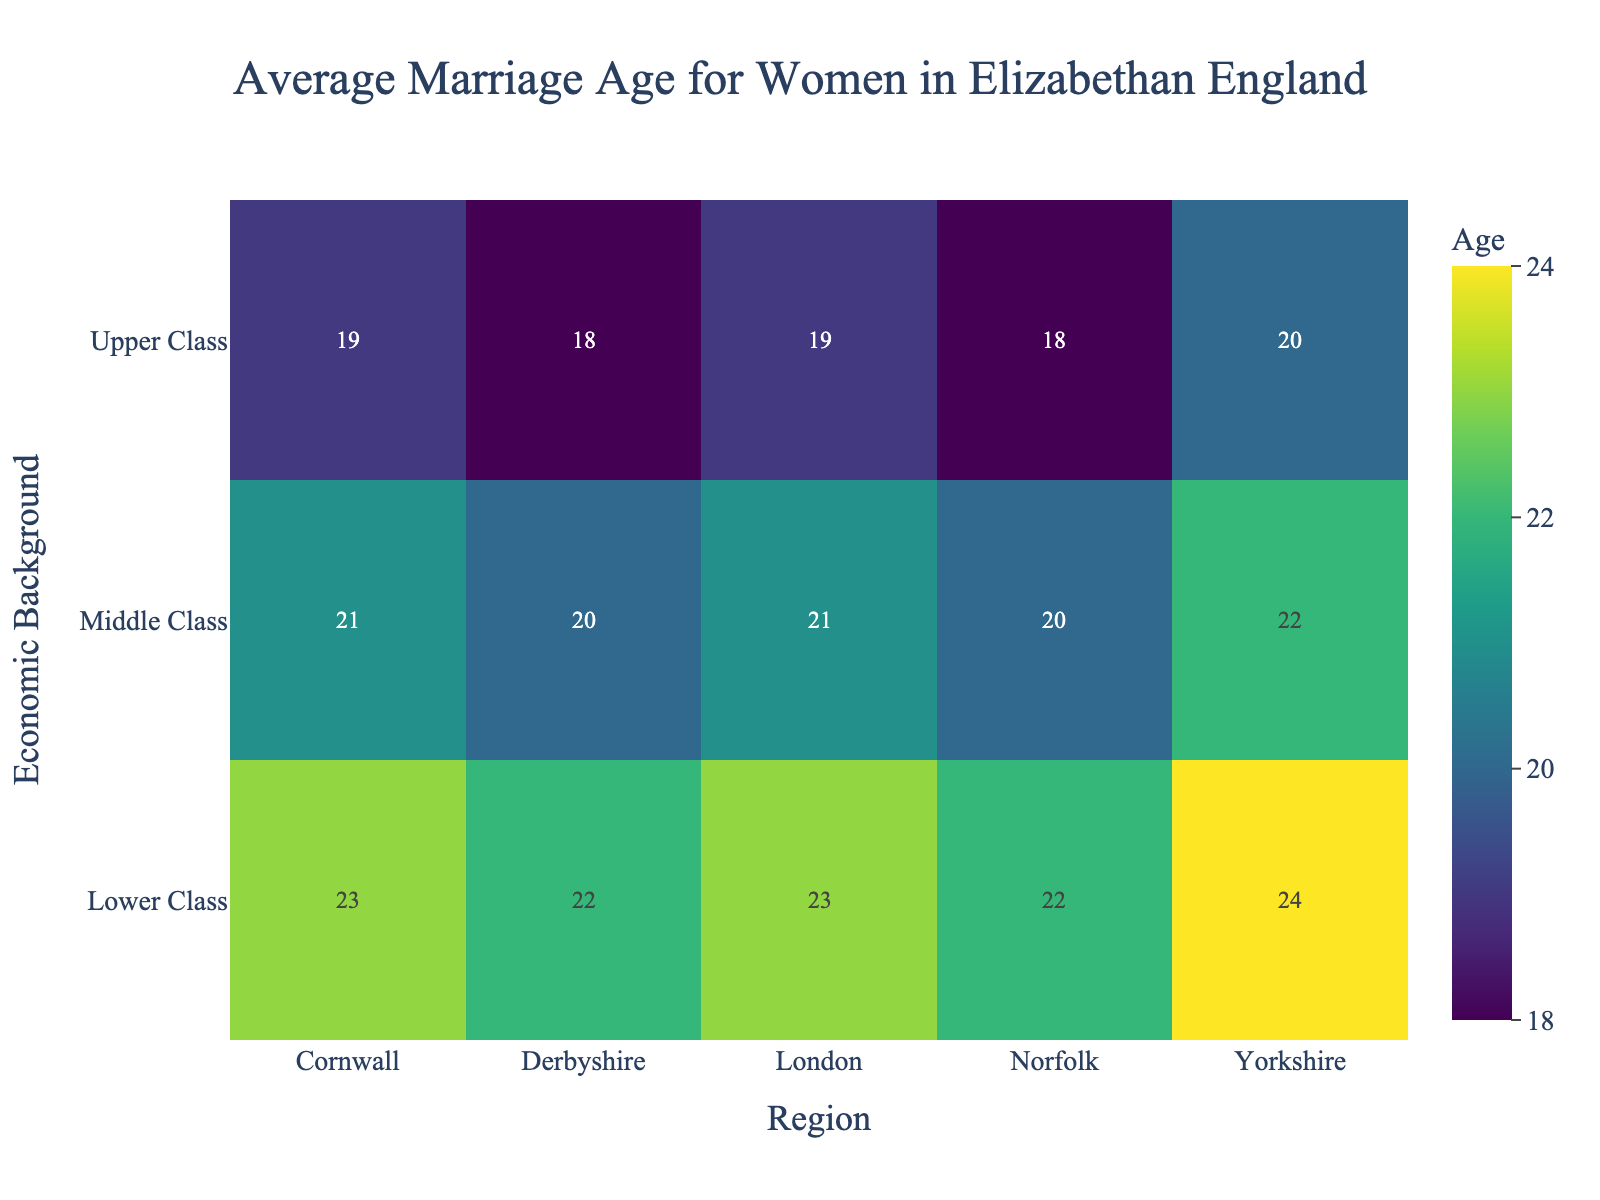What is the title of the figure? The title is usually found at the top of the figure. It provides an overview of what the heatmap is about. In this case, it tells us the subject is the "Average Marriage Age for Women in Elizabethan England."
Answer: Average Marriage Age for Women in Elizabethan England Which region has the highest average marriage age for Lower Class women? By looking at the row for Lower Class women in the heatmap, we can identify the highest marriage age. In this case, Yorkshire has the highest average marriage age for Lower Class women, which is 24.
Answer: Yorkshire What is the average marriage age for Middle Class women in Derbyshire? Locate the row corresponding to Middle Class and the column corresponding to Derbyshire. The intersection gives the average marriage age. Here, it is 20.
Answer: 20 How does the average marriage age for Lower Class women in Norfolk compare to those in Cornwall? Find the values for Lower Class in both Norfolk and Cornwall and compare them. Norfolk has an average age of 22, and Cornwall has an average age of 23.
Answer: Norfolk: 22, Cornwall: 23 What is the range of average marriage ages for Upper Class women across all regions? The range can be found by locating the minimum and maximum values for Upper Class women across the regions. The smallest value is 18 (Norfolk and Derbyshire) and the largest is 20 (Yorkshire). The range is 20 - 18 = 2.
Answer: 2 Which economic background group has the smallest variation in average marriage ages across all regions? To determine the smallest variation, calculate the range for each economic group's average marriage ages. Upper Class varies from 18 to 20 (range of 2), Middle Class varies from 20 to 22 (range of 2), and Lower Class varies from 22 to 24 (range of 2). All groups have the same variation.
Answer: Upper Class, Middle Class, Lower Class What is the average marriage age for Lower Class women across all regions? Add the average marriage ages for Lower Class women in each region and divide by the number of regions (23+24+22+23+22). The total is 114, and there are 5 regions. The average is 114/5 = 22.8.
Answer: 22.8 Is there a region where all economic backgrounds marry at the same age? Examine each region's values across all economic backgrounds. None of the regions have the same average marriage age for all economic backgrounds.
Answer: No 